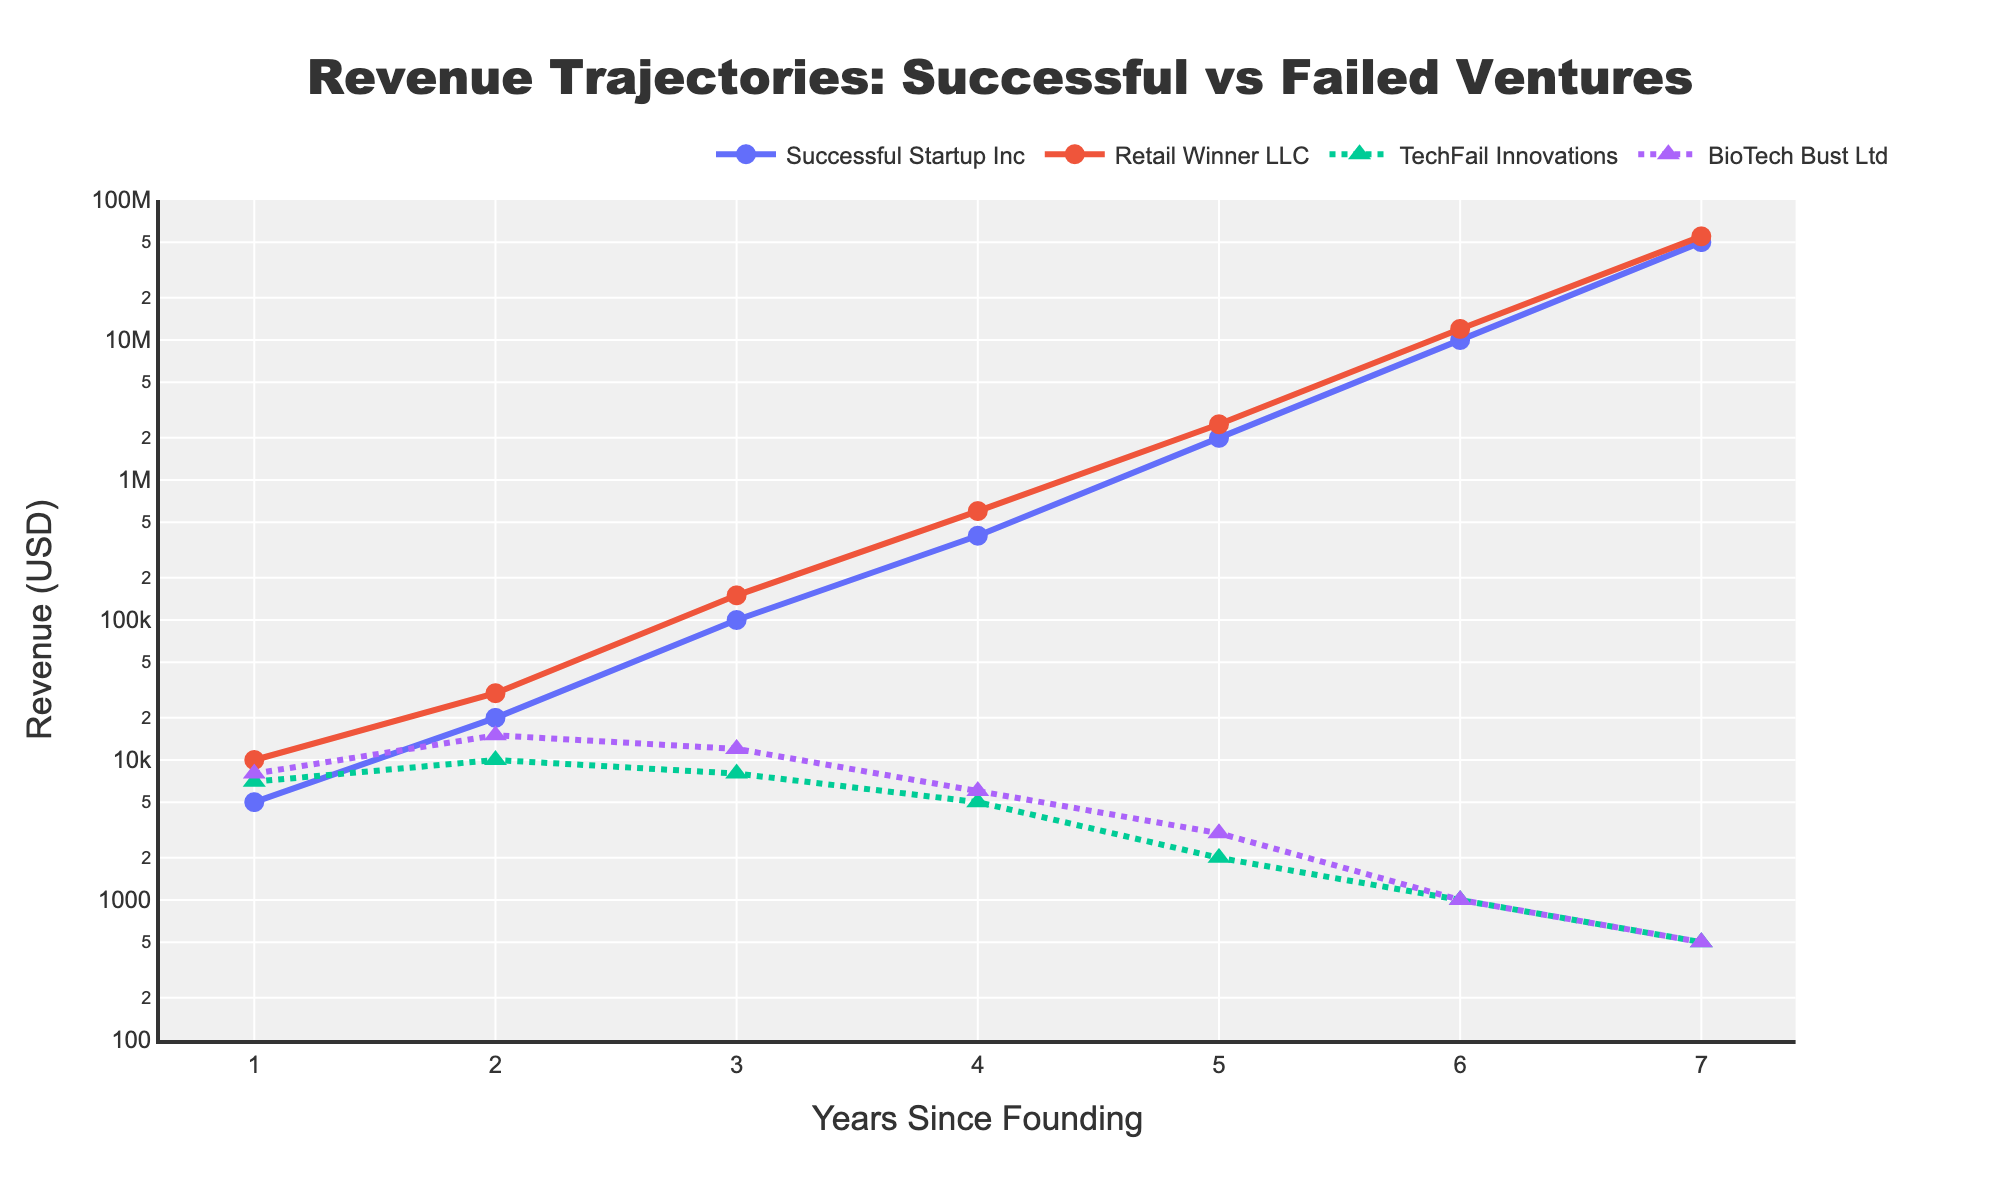Which companies are included in the figure? The figure includes four companies as indicated by the legend and the different lines on the plot.
Answer: Successful Startup Inc, TechFail Innovations, Retail Winner LLC, BioTech Bust Ltd What does the axis represent? The x-axis represents the years since founding, and the y-axis represents the revenue in USD on a logarithmic scale.
Answer: Years on x-axis and revenue in USD on y-axis Which companies show a declining revenue trajectory over the years? The lines for TechFail Innovations and BioTech Bust Ltd show a declining trend in revenue over the years, indicated by the lines sloping downward.
Answer: TechFail Innovations, BioTech Bust Ltd How does the revenue of Successful Startup Inc. in year 3 compare to that of TechFail Innovations in the same year? Successfully Startup Inc's revenue is much higher than that of TechFail Innovations in year 3, as indicated by Successful Startup Inc's line being at a higher position on the y-axis.
Answer: Successful Startup Inc's revenue is much higher Which company has the highest revenue in year 7 and what is the approximate value? The company with the highest revenue in year 7 is Retail Winner LLC, with an approximate revenue of 55,000,000 USD as indicated by its position on the y-axis.
Answer: Retail Winner LLC, 55,000,000 USD What is the common pattern in the revenue trajectory of the successful ventures (Successful Startup Inc and Retail Winner LLC)? Both successful ventures show a steep upward trend in their revenue on the logarithmic scale, indicating exponential growth over the years.
Answer: Steep upward trend, exponential growth Compare the revenue of BioTech Bust Ltd in year 1 and year 7. BioTech Bust Ltd's revenue in year 1 is 8,000 USD, whereas in year 7 it is 500 USD, showing a significant decline as seen by the downward slope of its line.
Answer: Decreased from 8,000 USD to 500 USD Does Retail Winner LLC show consistent revenue growth, and if so, how does it compare to Successful Startup Inc? Yes, Retail Winner LLC shows consistent revenue growth, and its trajectory is nearly parallel to that of Successful Startup Inc, indicating similar exponential growth patterns.
Answer: Consistent growth, similar to Successful Startup Inc Overall, what can you infer about the success of entrepreneurial ventures with a declining revenue trajectory? Ventures with declining revenue trajectories, like TechFail Innovations and BioTech Bust Ltd, tend not to survive in the long term, as indicated by their consistently falling revenues over the years.
Answer: Likely to fail in the long term 